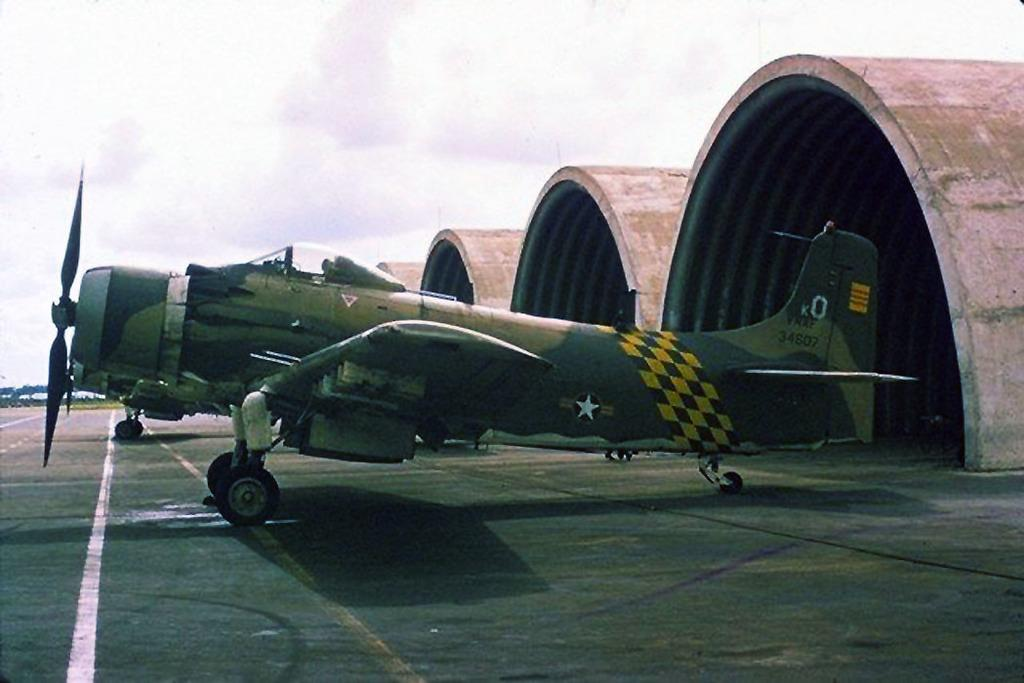Provide a one-sentence caption for the provided image. An old fighter airplane is outside of the hangers and it has a number 0 on its tail wing. 